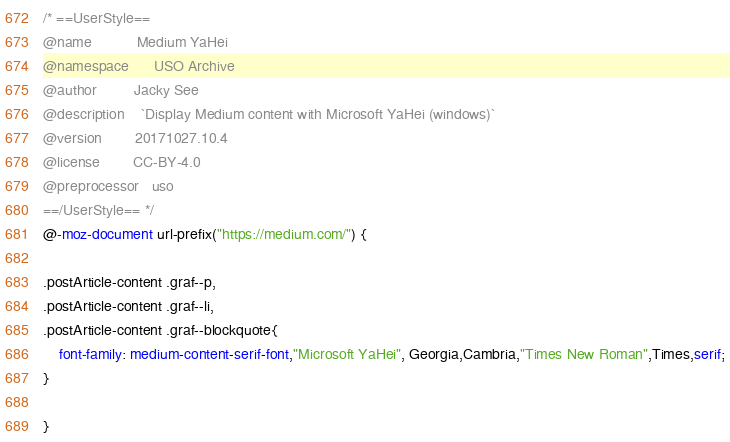<code> <loc_0><loc_0><loc_500><loc_500><_CSS_>/* ==UserStyle==
@name           Medium YaHei
@namespace      USO Archive
@author         Jacky See
@description    `Display Medium content with Microsoft YaHei (windows)`
@version        20171027.10.4
@license        CC-BY-4.0
@preprocessor   uso
==/UserStyle== */
@-moz-document url-prefix("https://medium.com/") {

.postArticle-content .graf--p,
.postArticle-content .graf--li,
.postArticle-content .graf--blockquote{
    font-family: medium-content-serif-font,"Microsoft YaHei", Georgia,Cambria,"Times New Roman",Times,serif;
}

}</code> 